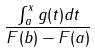<formula> <loc_0><loc_0><loc_500><loc_500>\frac { \int _ { a } ^ { x } g ( t ) d t } { F ( b ) - F ( a ) }</formula> 